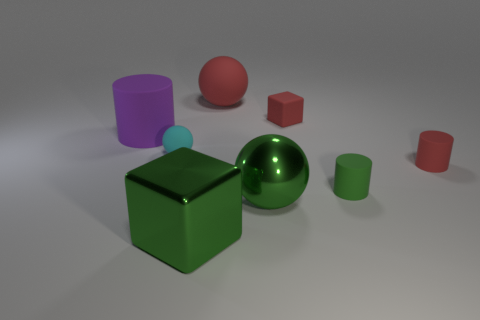Do the metallic sphere and the cyan object have the same size?
Offer a very short reply. No. There is a large green thing that is in front of the big ball in front of the tiny cyan rubber sphere; is there a green metal thing behind it?
Make the answer very short. Yes. There is a big sphere that is made of the same material as the tiny red cube; what is its color?
Provide a succinct answer. Red. There is a big rubber object that is in front of the rubber cube; is its color the same as the tiny ball?
Give a very brief answer. No. What size is the matte cylinder that is to the right of the green object that is to the right of the block on the right side of the large red ball?
Provide a short and direct response. Small. The other matte object that is the same size as the purple rubber thing is what shape?
Your answer should be very brief. Sphere. Are the ball that is to the right of the big matte sphere and the green block made of the same material?
Your answer should be compact. Yes. How big is the block that is in front of the red rubber object that is right of the tiny green rubber cylinder?
Your response must be concise. Large. There is a ball that is both in front of the big matte cylinder and to the right of the tiny cyan thing; what color is it?
Offer a very short reply. Green. What is the material of the red sphere that is the same size as the purple matte thing?
Provide a succinct answer. Rubber. 